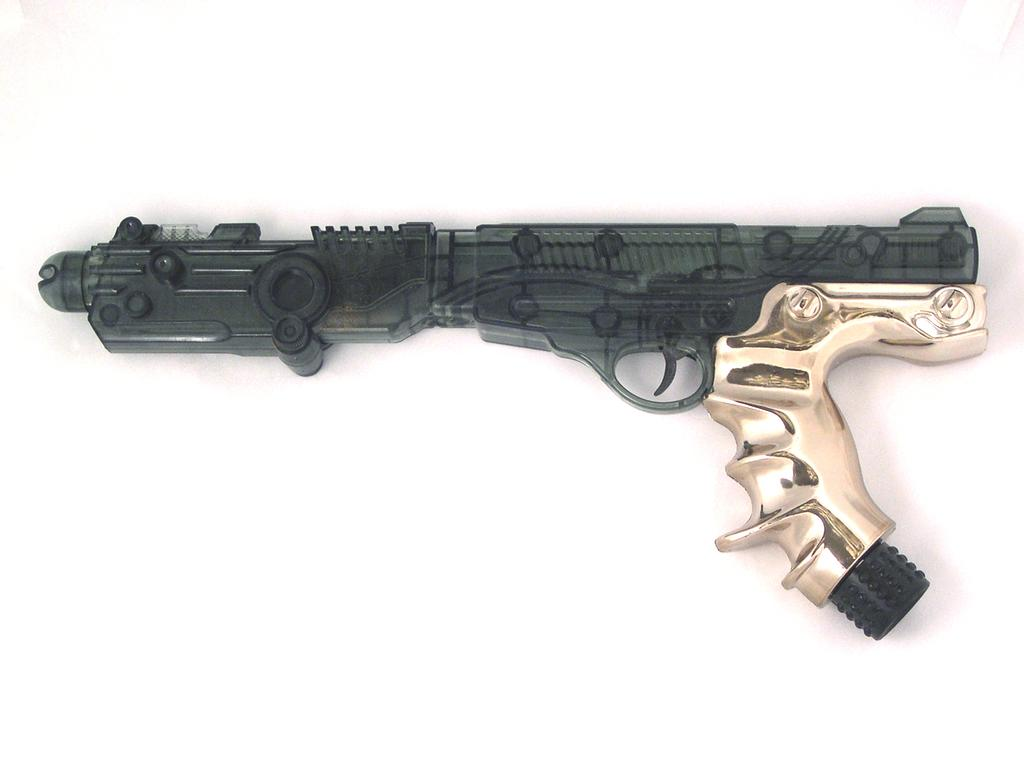What object is the main focus of the image? There is a gun in the image. What is the color of the surface on which the gun is placed? The gun is on a white surface. What type of jam is being spread on the income tax form in the image? There is no jam or income tax form present in the image; it only features a gun on a white surface. 